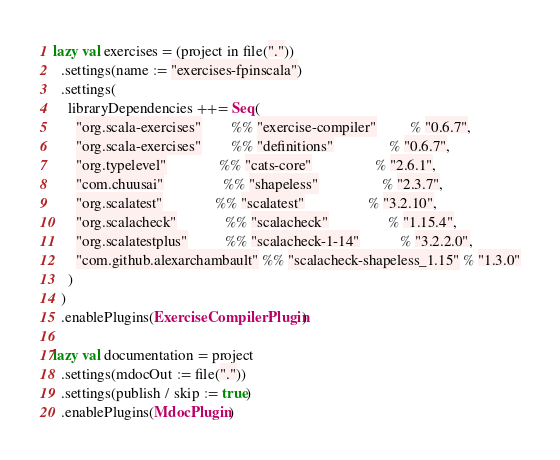Convert code to text. <code><loc_0><loc_0><loc_500><loc_500><_Scala_>
lazy val exercises = (project in file("."))
  .settings(name := "exercises-fpinscala")
  .settings(
    libraryDependencies ++= Seq(
      "org.scala-exercises"        %% "exercise-compiler"         % "0.6.7",
      "org.scala-exercises"        %% "definitions"               % "0.6.7",
      "org.typelevel"              %% "cats-core"                 % "2.6.1",
      "com.chuusai"                %% "shapeless"                 % "2.3.7",
      "org.scalatest"              %% "scalatest"                 % "3.2.10",
      "org.scalacheck"             %% "scalacheck"                % "1.15.4",
      "org.scalatestplus"          %% "scalacheck-1-14"           % "3.2.2.0",
      "com.github.alexarchambault" %% "scalacheck-shapeless_1.15" % "1.3.0"
    )
  )
  .enablePlugins(ExerciseCompilerPlugin)

lazy val documentation = project
  .settings(mdocOut := file("."))
  .settings(publish / skip := true)
  .enablePlugins(MdocPlugin)
</code> 